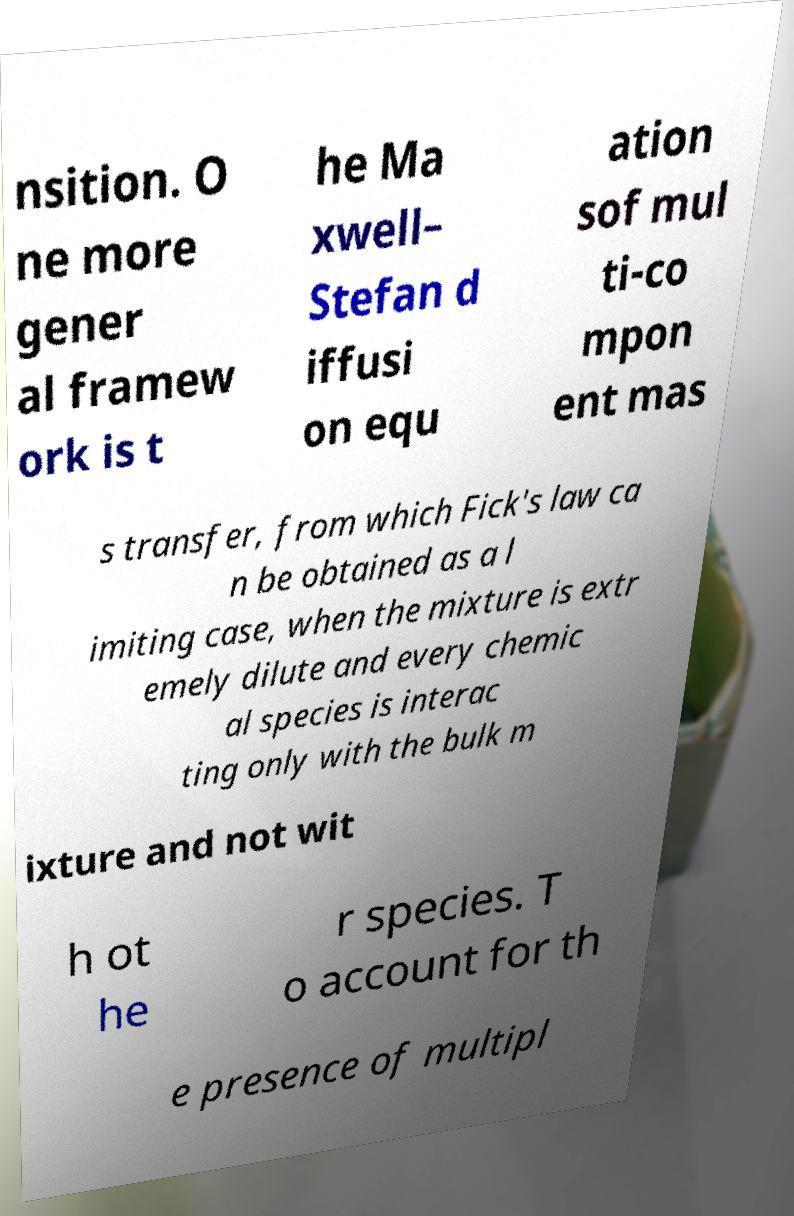What messages or text are displayed in this image? I need them in a readable, typed format. nsition. O ne more gener al framew ork is t he Ma xwell– Stefan d iffusi on equ ation sof mul ti-co mpon ent mas s transfer, from which Fick's law ca n be obtained as a l imiting case, when the mixture is extr emely dilute and every chemic al species is interac ting only with the bulk m ixture and not wit h ot he r species. T o account for th e presence of multipl 